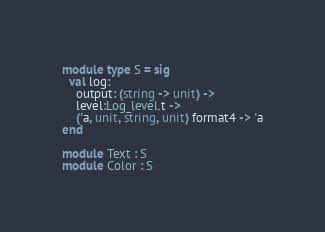Convert code to text. <code><loc_0><loc_0><loc_500><loc_500><_OCaml_>module type S = sig
  val log:
    output: (string -> unit) ->
    level:Log_level.t ->
    ('a, unit, string, unit) format4 -> 'a
end

module Text : S
module Color : S
</code> 